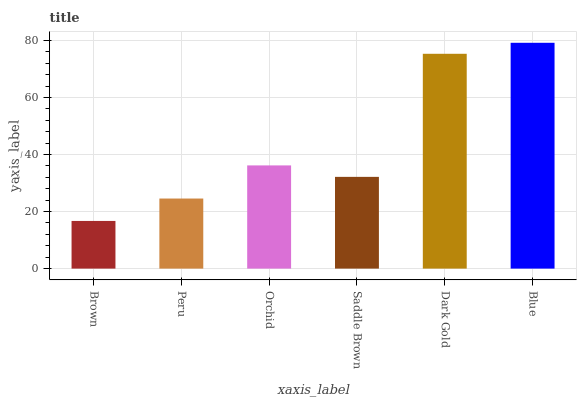Is Brown the minimum?
Answer yes or no. Yes. Is Blue the maximum?
Answer yes or no. Yes. Is Peru the minimum?
Answer yes or no. No. Is Peru the maximum?
Answer yes or no. No. Is Peru greater than Brown?
Answer yes or no. Yes. Is Brown less than Peru?
Answer yes or no. Yes. Is Brown greater than Peru?
Answer yes or no. No. Is Peru less than Brown?
Answer yes or no. No. Is Orchid the high median?
Answer yes or no. Yes. Is Saddle Brown the low median?
Answer yes or no. Yes. Is Peru the high median?
Answer yes or no. No. Is Orchid the low median?
Answer yes or no. No. 